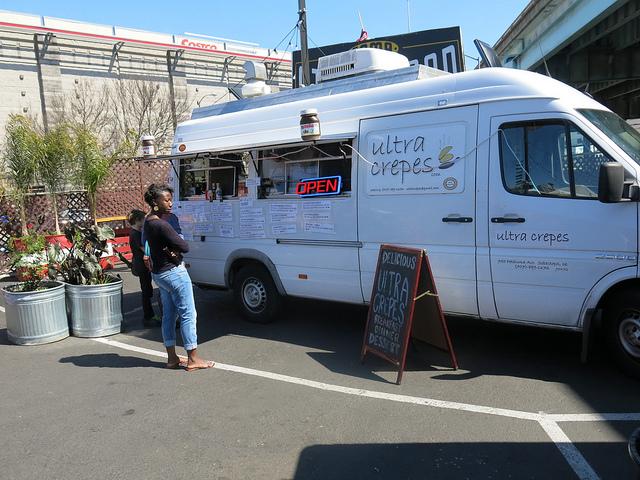Is the van clean?
Be succinct. Yes. What material is the planters made of?
Write a very short answer. Aluminum. What is an item that is sold from this truck?
Answer briefly. Crepes. 